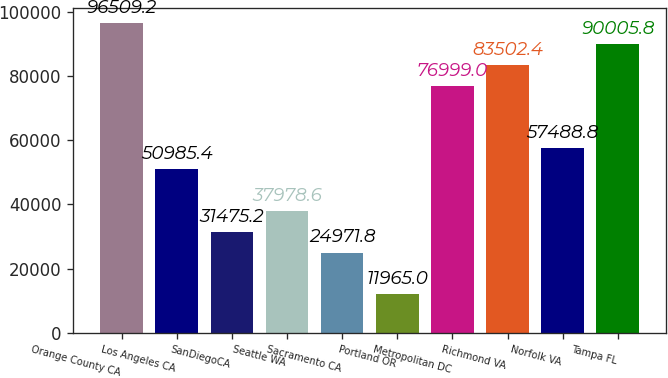<chart> <loc_0><loc_0><loc_500><loc_500><bar_chart><fcel>Orange County CA<fcel>Los Angeles CA<fcel>SanDiegoCA<fcel>Seattle WA<fcel>Sacramento CA<fcel>Portland OR<fcel>Metropolitan DC<fcel>Richmond VA<fcel>Norfolk VA<fcel>Tampa FL<nl><fcel>96509.2<fcel>50985.4<fcel>31475.2<fcel>37978.6<fcel>24971.8<fcel>11965<fcel>76999<fcel>83502.4<fcel>57488.8<fcel>90005.8<nl></chart> 